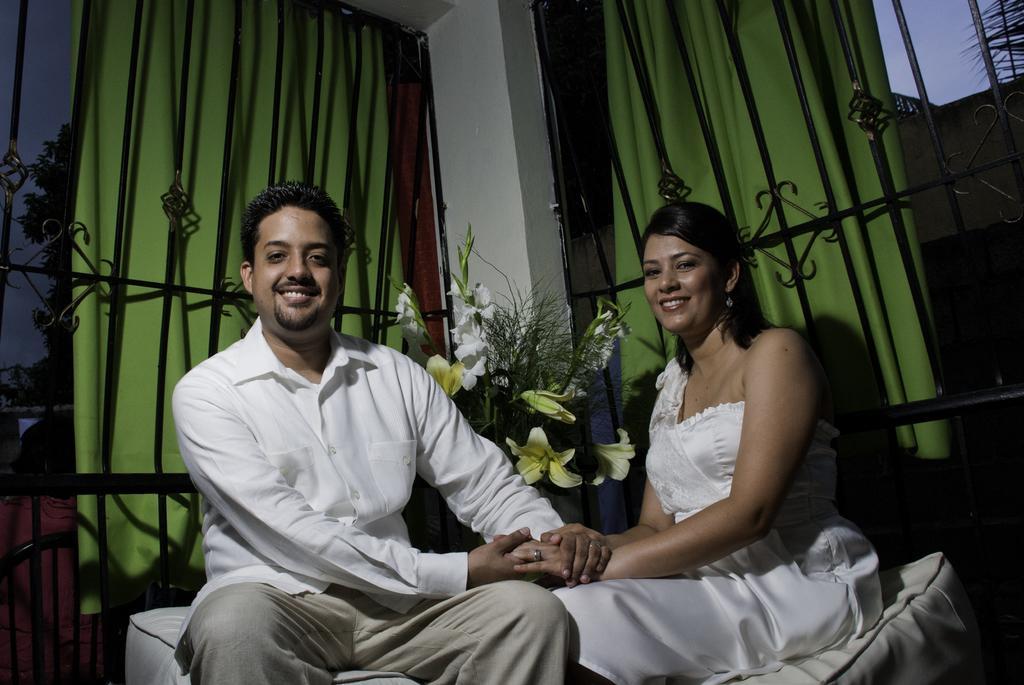Could you give a brief overview of what you see in this image? In the center of the image we can see two persons are sitting on some object and they are smiling. In the background there is a wall, bouquet and fencing. Through the fencing, we can see the sky, leaves, curtains and a few other objects. 